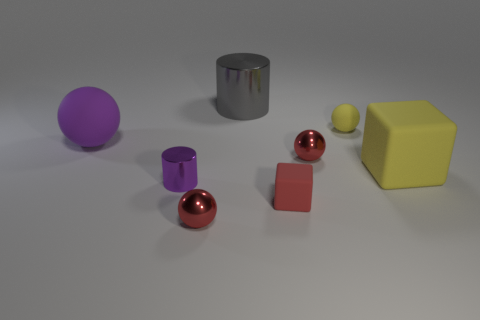Are there fewer tiny gray spheres than purple cylinders?
Your answer should be compact. Yes. There is a metallic thing that is in front of the red rubber object; is it the same size as the rubber ball that is right of the gray thing?
Offer a terse response. Yes. How many gray objects are metallic balls or large balls?
Ensure brevity in your answer.  0. What is the size of the rubber thing that is the same color as the tiny shiny cylinder?
Your answer should be compact. Large. Is the number of large gray cylinders greater than the number of things?
Provide a short and direct response. No. Do the small cube and the big matte block have the same color?
Ensure brevity in your answer.  No. How many objects are either large metal objects or spheres behind the small purple cylinder?
Provide a succinct answer. 4. What number of other objects are there of the same shape as the gray metallic object?
Your answer should be very brief. 1. Are there fewer large cubes that are to the left of the large purple rubber ball than small red spheres that are on the right side of the large rubber block?
Offer a very short reply. No. Is there anything else that is made of the same material as the big gray object?
Your answer should be very brief. Yes. 